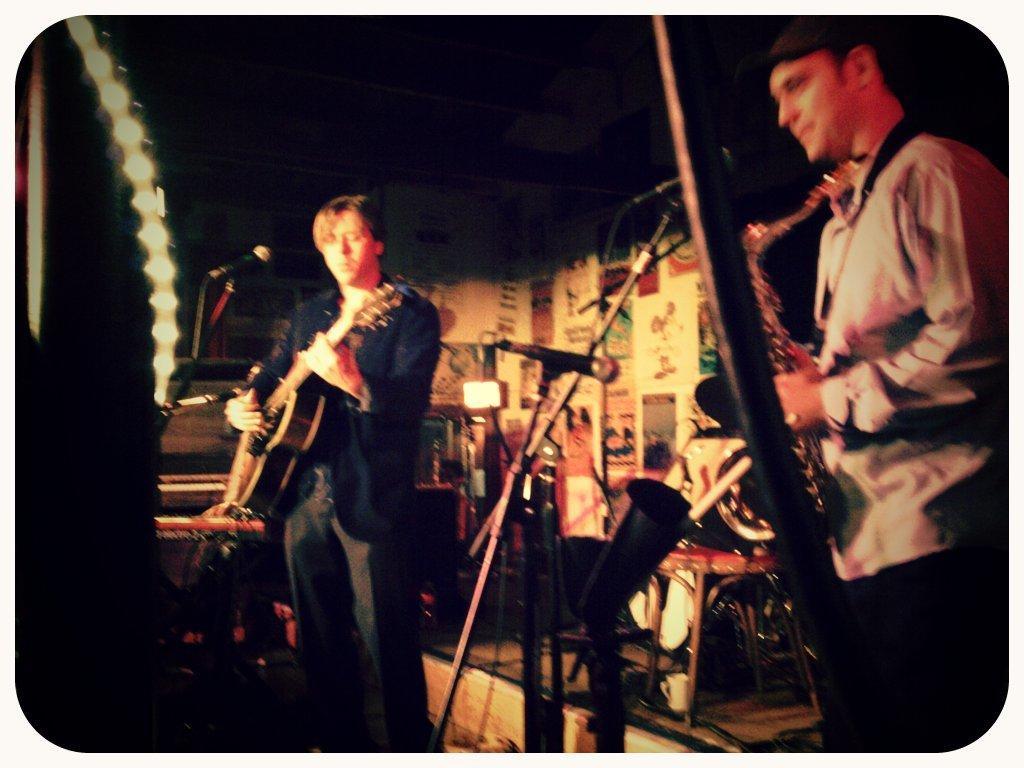Can you describe this image briefly? In this image we can see two people playing musical instruments. There is a mic. In the background of the image there is wall. There is a chair. At the top of the image there is ceiling. 